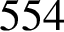<formula> <loc_0><loc_0><loc_500><loc_500>5 5 4</formula> 